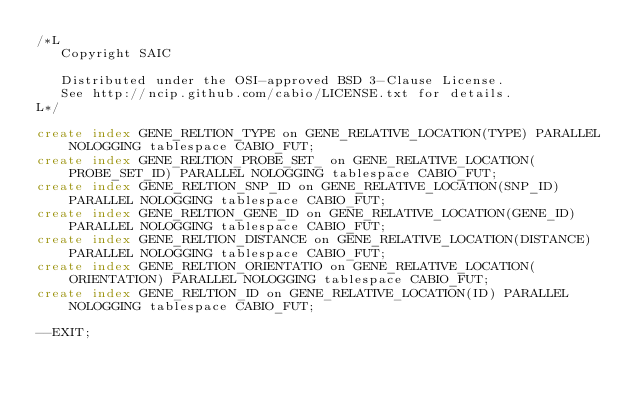Convert code to text. <code><loc_0><loc_0><loc_500><loc_500><_SQL_>/*L
   Copyright SAIC

   Distributed under the OSI-approved BSD 3-Clause License.
   See http://ncip.github.com/cabio/LICENSE.txt for details.
L*/

create index GENE_RELTION_TYPE on GENE_RELATIVE_LOCATION(TYPE) PARALLEL NOLOGGING tablespace CABIO_FUT;
create index GENE_RELTION_PROBE_SET_ on GENE_RELATIVE_LOCATION(PROBE_SET_ID) PARALLEL NOLOGGING tablespace CABIO_FUT;
create index GENE_RELTION_SNP_ID on GENE_RELATIVE_LOCATION(SNP_ID) PARALLEL NOLOGGING tablespace CABIO_FUT;
create index GENE_RELTION_GENE_ID on GENE_RELATIVE_LOCATION(GENE_ID) PARALLEL NOLOGGING tablespace CABIO_FUT;
create index GENE_RELTION_DISTANCE on GENE_RELATIVE_LOCATION(DISTANCE) PARALLEL NOLOGGING tablespace CABIO_FUT;
create index GENE_RELTION_ORIENTATIO on GENE_RELATIVE_LOCATION(ORIENTATION) PARALLEL NOLOGGING tablespace CABIO_FUT;
create index GENE_RELTION_ID on GENE_RELATIVE_LOCATION(ID) PARALLEL NOLOGGING tablespace CABIO_FUT;

--EXIT;
</code> 